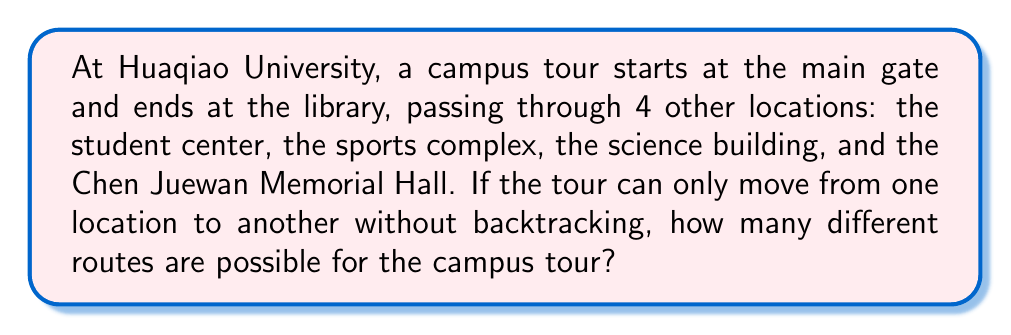Could you help me with this problem? Let's approach this step-by-step:

1) We have 6 locations in total:
   - Main gate (start)
   - Student center
   - Sports complex
   - Science building
   - Chen Juewan Memorial Hall
   - Library (end)

2) The tour must start at the main gate and end at the library. This means we need to arrange the middle 4 locations.

3) This is a permutation problem. We need to find the number of ways to arrange 4 distinct objects.

4) The formula for permutations of n distinct objects is:

   $$P(n) = n!$$

5) In this case, n = 4, so we calculate:

   $$P(4) = 4! = 4 \times 3 \times 2 \times 1 = 24$$

6) Therefore, there are 24 different ways to arrange the 4 middle locations.

7) Each of these arrangements represents a unique route from the main gate to the library.
Answer: 24 